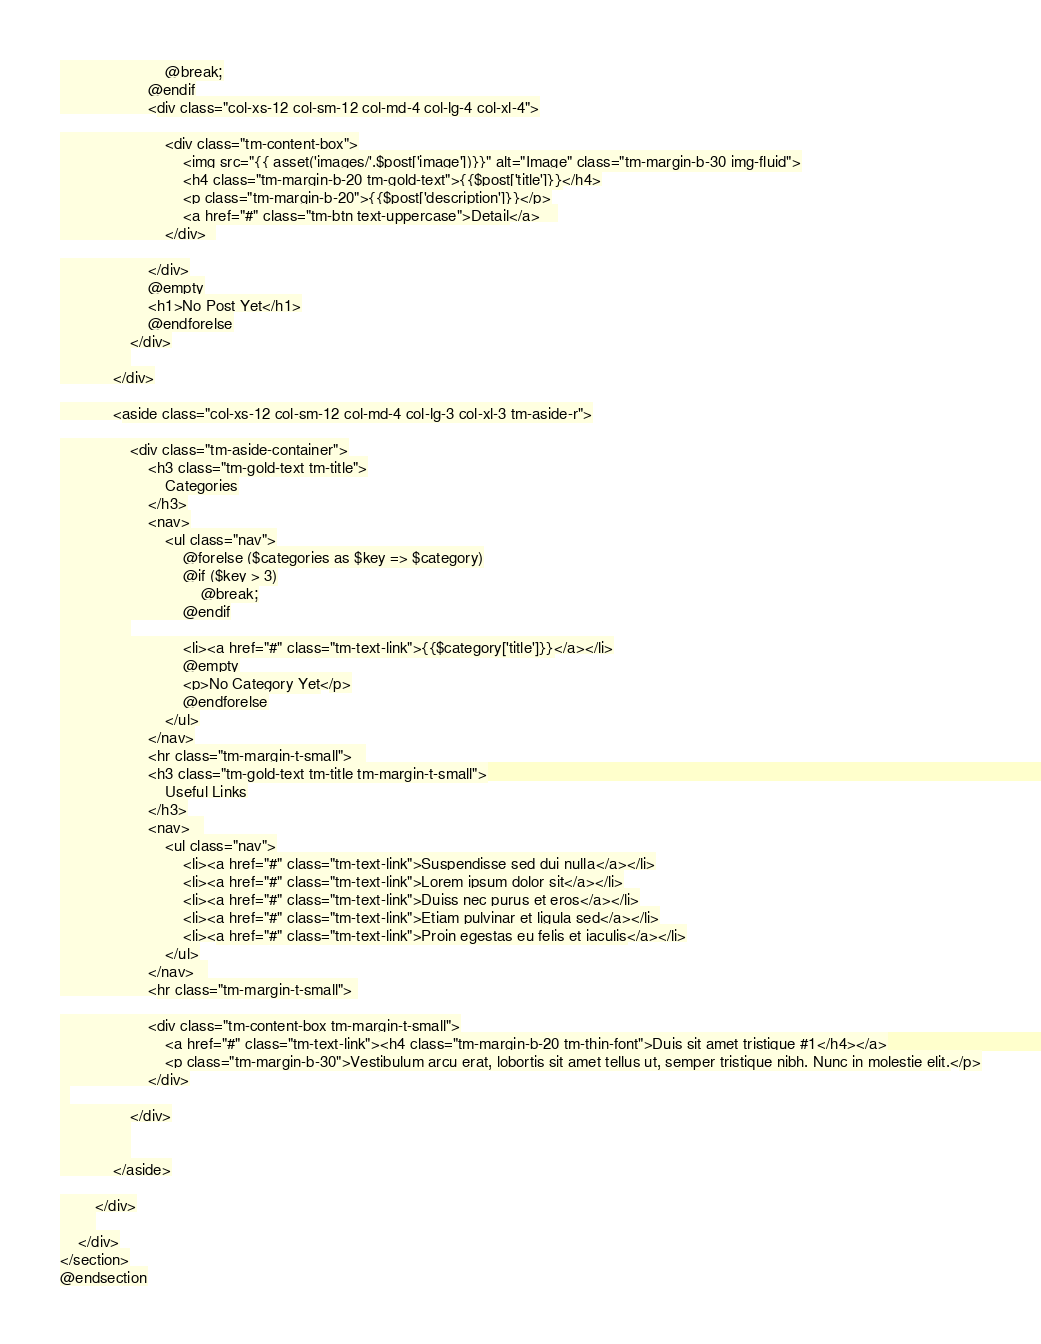Convert code to text. <code><loc_0><loc_0><loc_500><loc_500><_PHP_>                        @break;
                    @endif
                    <div class="col-xs-12 col-sm-12 col-md-4 col-lg-4 col-xl-4">

                        <div class="tm-content-box">
                            <img src="{{ asset('images/'.$post['image'])}}" alt="Image" class="tm-margin-b-30 img-fluid">
                            <h4 class="tm-margin-b-20 tm-gold-text">{{$post['title']}}</h4>
                            <p class="tm-margin-b-20">{{$post['description']}}</p>
                            <a href="#" class="tm-btn text-uppercase">Detail</a>    
                        </div>  

                    </div>
                    @empty
                    <h1>No Post Yet</h1>
                    @endforelse
                </div>
                
            </div>

            <aside class="col-xs-12 col-sm-12 col-md-4 col-lg-3 col-xl-3 tm-aside-r">

                <div class="tm-aside-container">
                    <h3 class="tm-gold-text tm-title">
                        Categories
                    </h3>
                    <nav>
                        <ul class="nav">
                            @forelse ($categories as $key => $category)
                            @if ($key > 3)
                                @break;
                            @endif
                
                            <li><a href="#" class="tm-text-link">{{$category['title']}}</a></li>
                            @empty
                            <p>No Category Yet</p>
                            @endforelse
                        </ul>
                    </nav>
                    <hr class="tm-margin-t-small">   
                    <h3 class="tm-gold-text tm-title tm-margin-t-small">
                        Useful Links
                    </h3>
                    <nav>   
                        <ul class="nav">
                            <li><a href="#" class="tm-text-link">Suspendisse sed dui nulla</a></li>
                            <li><a href="#" class="tm-text-link">Lorem ipsum dolor sit</a></li>
                            <li><a href="#" class="tm-text-link">Duiss nec purus et eros</a></li>
                            <li><a href="#" class="tm-text-link">Etiam pulvinar et ligula sed</a></li>
                            <li><a href="#" class="tm-text-link">Proin egestas eu felis et iaculis</a></li>
                        </ul>
                    </nav>   
                    <hr class="tm-margin-t-small"> 

                    <div class="tm-content-box tm-margin-t-small">
                        <a href="#" class="tm-text-link"><h4 class="tm-margin-b-20 tm-thin-font">Duis sit amet tristique #1</h4></a>
                        <p class="tm-margin-b-30">Vestibulum arcu erat, lobortis sit amet tellus ut, semper tristique nibh. Nunc in molestie elit.</p>
                    </div>
  
                </div>
                
                
            </aside>

        </div>
        
    </div>
</section>
@endsection</code> 